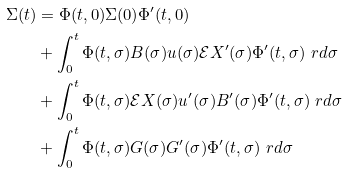Convert formula to latex. <formula><loc_0><loc_0><loc_500><loc_500>\Sigma ( t ) & = \Phi ( t , 0 ) \Sigma ( 0 ) \Phi ^ { \prime } ( t , 0 ) \\ & + \int _ { 0 } ^ { t } \Phi ( t , \sigma ) B ( \sigma ) u ( \sigma ) \mathcal { E } X ^ { \prime } ( \sigma ) \Phi ^ { \prime } ( t , \sigma ) \ r d \sigma \\ & + \int _ { 0 } ^ { t } \Phi ( t , \sigma ) \mathcal { E } X ( \sigma ) u ^ { \prime } ( \sigma ) B ^ { \prime } ( \sigma ) \Phi ^ { \prime } ( t , \sigma ) \ r d \sigma \\ & + \int _ { 0 } ^ { t } \Phi ( t , \sigma ) G ( \sigma ) G ^ { \prime } ( \sigma ) \Phi ^ { \prime } ( t , \sigma ) \ r d \sigma</formula> 